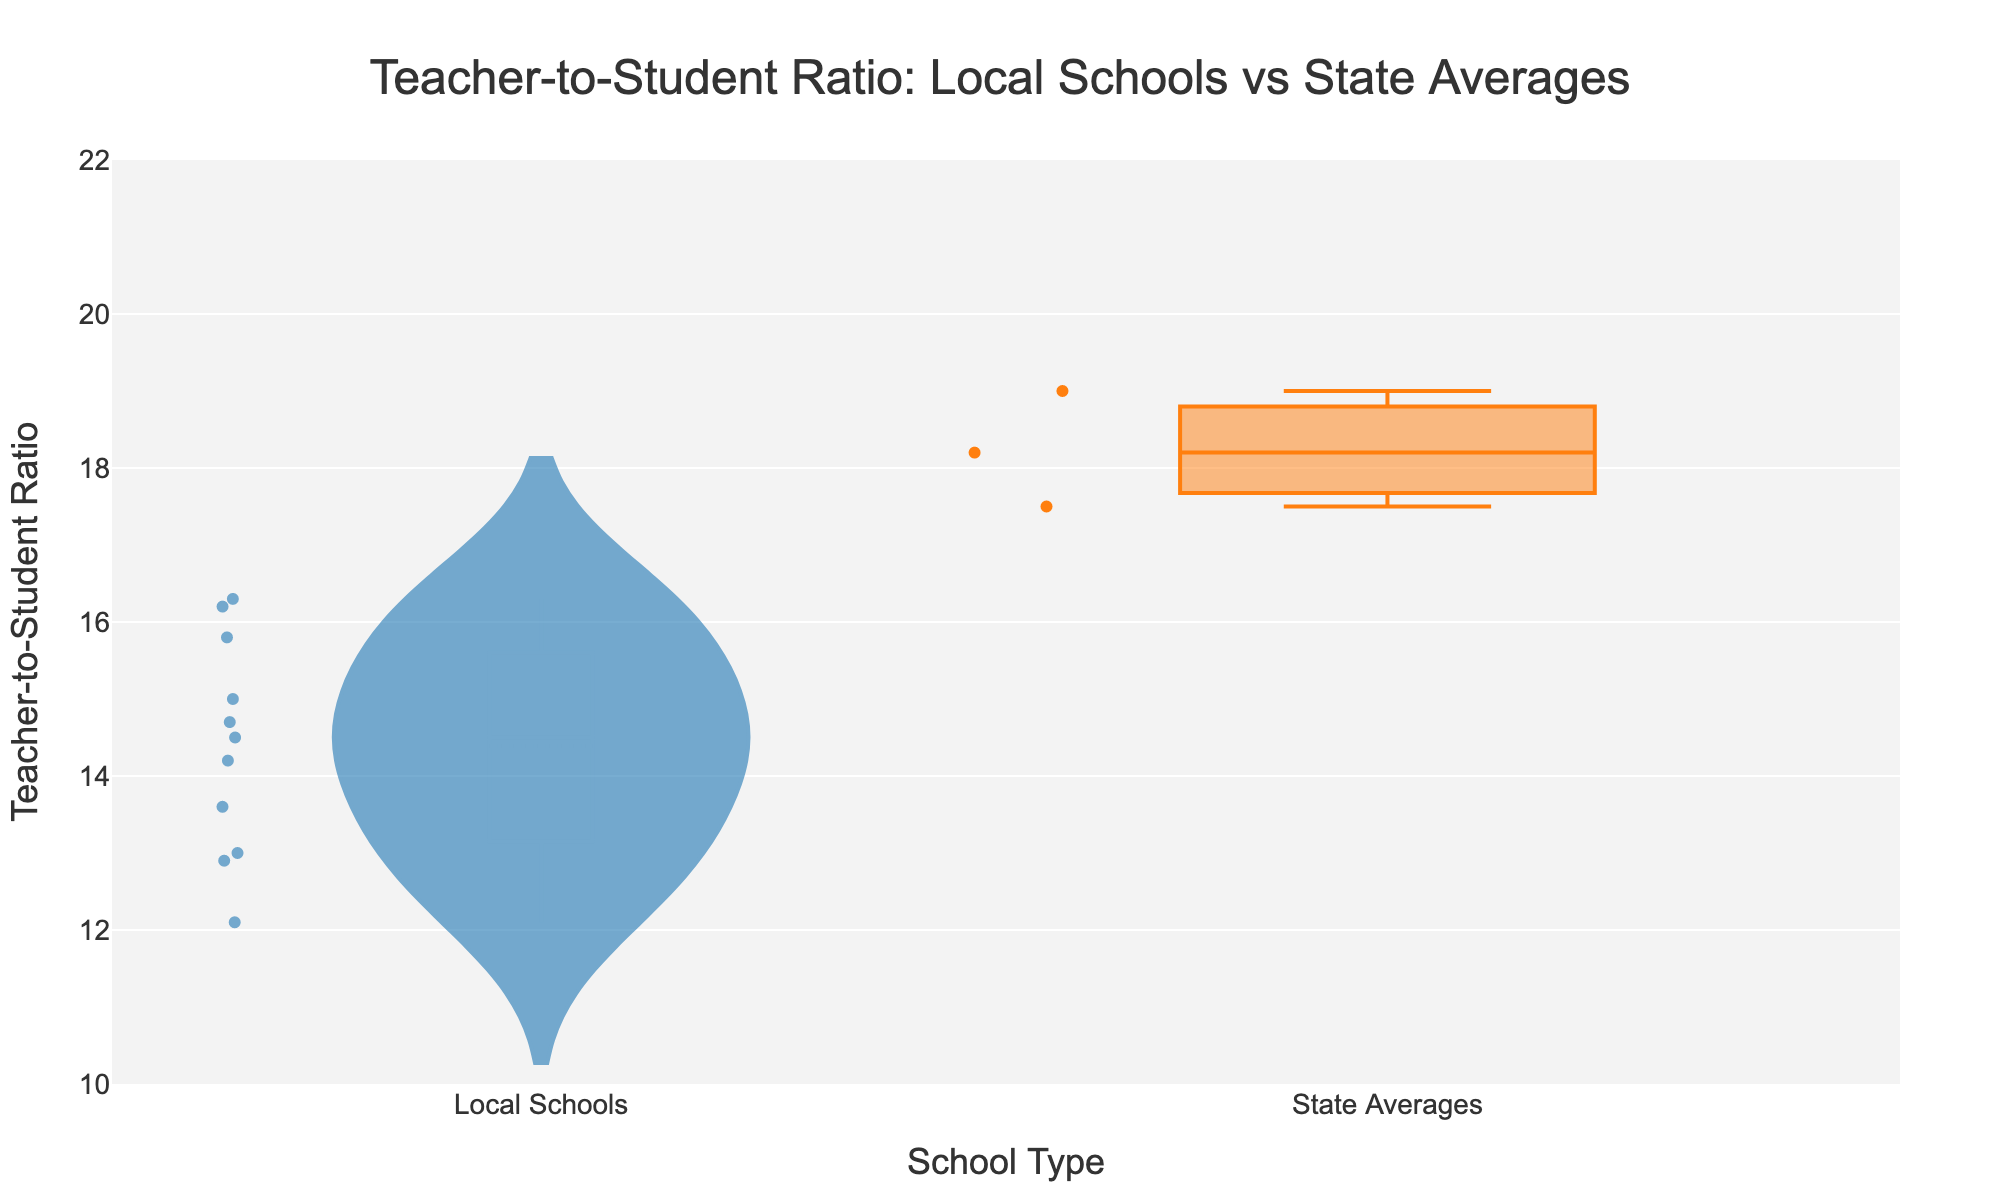what is the average Teacher-to-Student ratio for local schools? The average Teacher-to-Student ratio for local schools can be calculated by summing the individual ratios and dividing by the number of local schools. For local schools: (14.5 + 12.1 + 13.6 + 15.8 + 14.2 + 15.0 + 16.3 + 13.0 + 14.7 + 12.9 + 16.2) / 11 = 14.32
Answer: 14.32 What does the title of the figure indicate? The title of the figure gives context about the presented data. It mentions the comparison between Teacher-to-Student ratio in local schools versus state averages
Answer: Teacher-to-Student Ratio: Local Schools vs State Averages Which school type has a higher median Teacher-to-Student ratio? By examining the box plot overlay, the median for state averages (orange box plot) is indicated to be higher than the median for local schools (blue violin plot with box overlay)
Answer: State averages How many local schools are presented in the figure? The figure indicates that there are multiple local schools, each contributing to the Teacher-to-Student ratio distribution in the blue violin plot. By counting the schools provided in the dataset, we find 11 local schools
Answer: 11 What is the range of the Teacher-to-Student ratios for state averages? Looking at the box plot for state averages, the whiskers indicate the range from the minimum to maximum values. These are from 17.5 to 19.0
Answer: 17.5 to 19.0 Which group shows more variation in Teacher-to-Student ratios? By comparing the spread of the blue violin plot and the orange box plot, the local schools' violin plot is wider, showing more variation as opposed to the compact distribution in state averages' box plot
Answer: Local schools What is the lowest Teacher-to-Student ratio among local schools? Observing the lower end of the blue violin plot's distribution, the minimum ratio for local schools is approximately 12.1
Answer: 12.1 What does the median line in the violin plot represent? The median line in the violin plot represents the middle value of the Teacher-to-Student ratios for local schools, dividing the data into two halves
Answer: Median of local schools Does the data suggest local control of education might result in lower Teacher-to-Student ratios? The visual comparison indicates that local schools tend to have lower Teacher-to-Student ratios, with their median being lower than the state's median, supporting the suggestion that local control can result in better ratios
Answer: Yes 